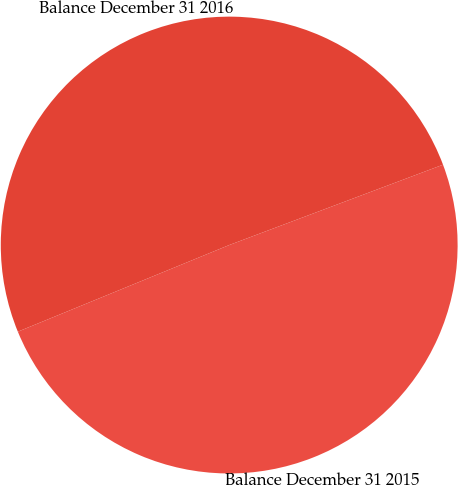Convert chart to OTSL. <chart><loc_0><loc_0><loc_500><loc_500><pie_chart><fcel>Balance December 31 2015<fcel>Balance December 31 2016<nl><fcel>49.53%<fcel>50.47%<nl></chart> 